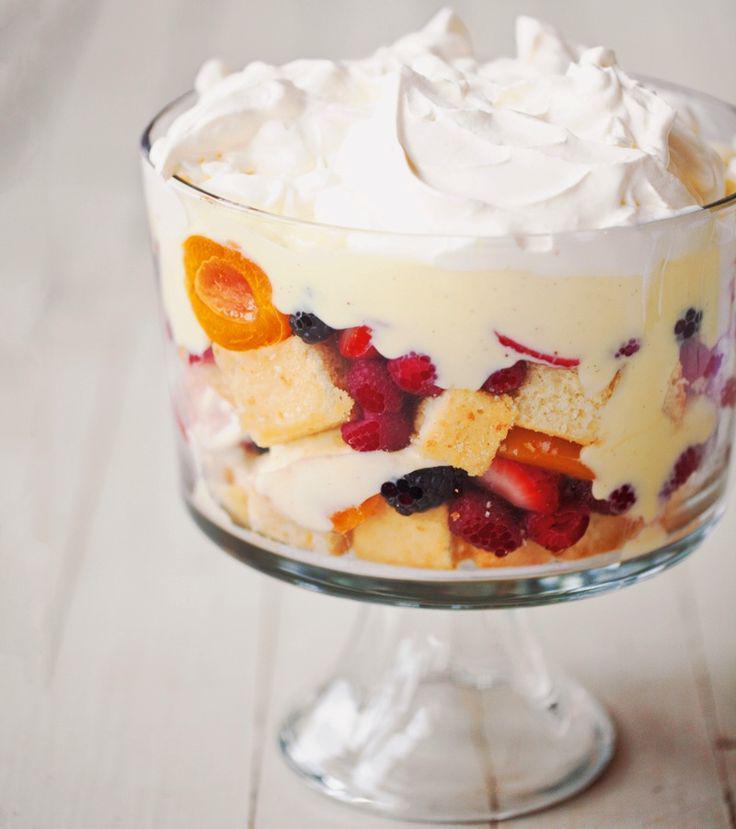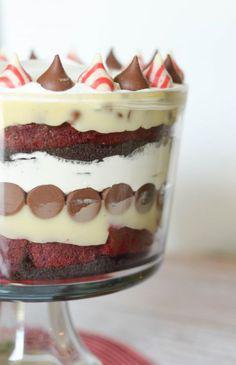The first image is the image on the left, the second image is the image on the right. Analyze the images presented: Is the assertion "there are blueberries on the top of the dessert in one of the images." valid? Answer yes or no. No. The first image is the image on the left, the second image is the image on the right. Assess this claim about the two images: "Strawberries and blueberries top one of the desserts depicted.". Correct or not? Answer yes or no. No. 